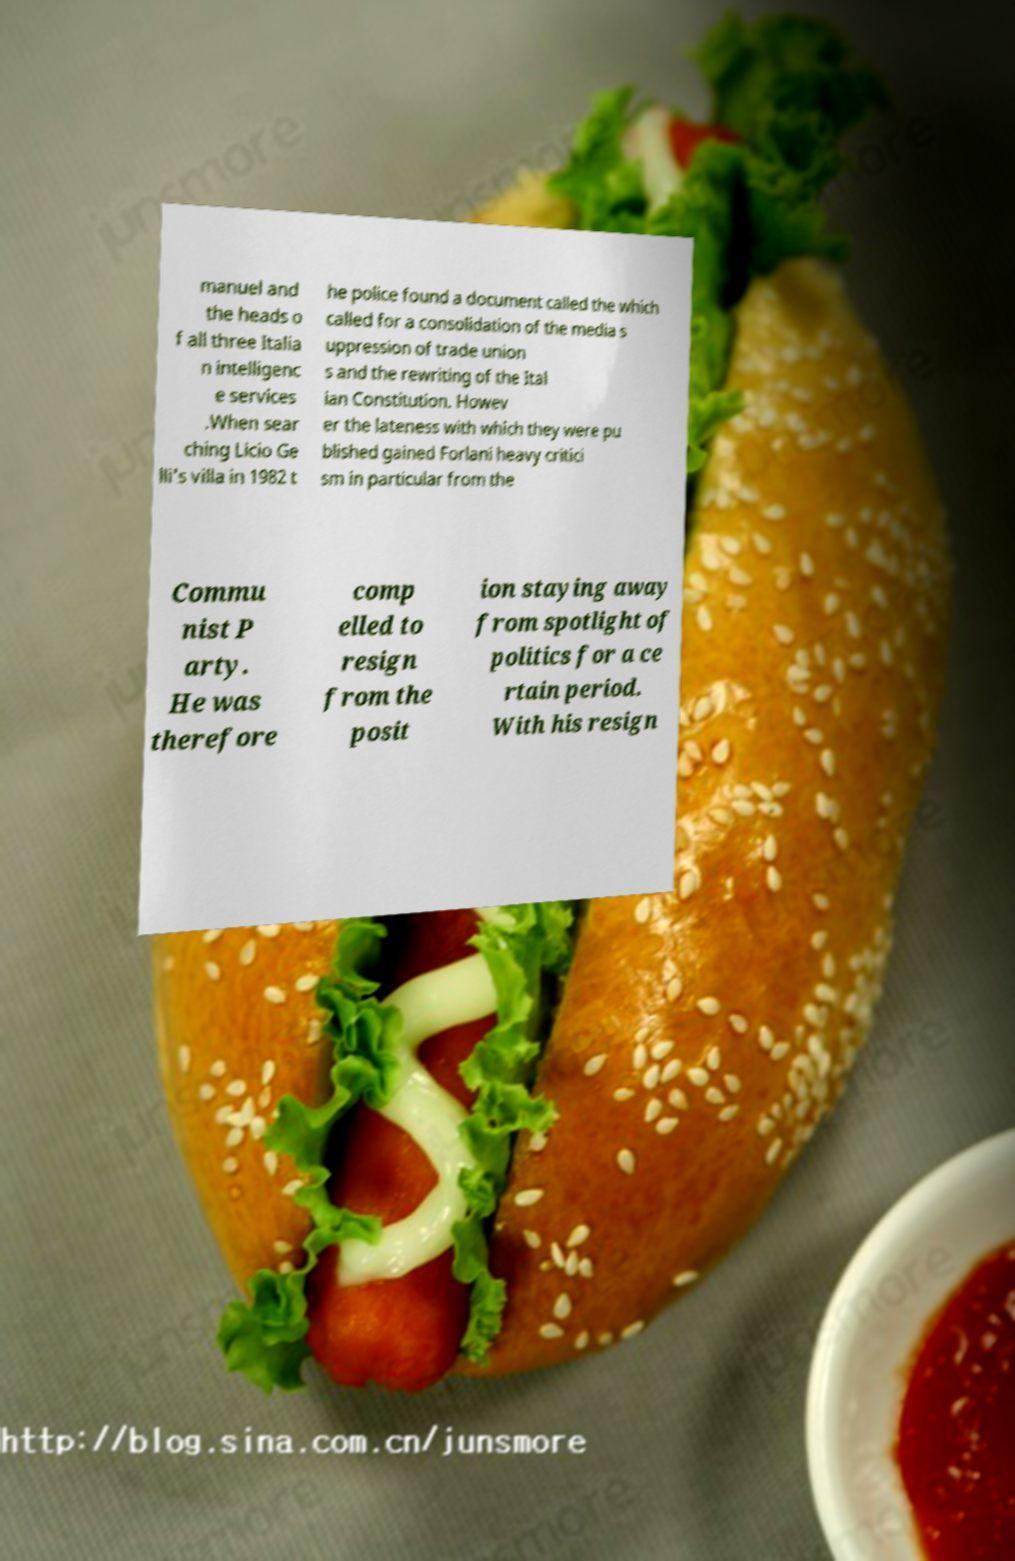Please identify and transcribe the text found in this image. manuel and the heads o f all three Italia n intelligenc e services .When sear ching Licio Ge lli's villa in 1982 t he police found a document called the which called for a consolidation of the media s uppression of trade union s and the rewriting of the Ital ian Constitution. Howev er the lateness with which they were pu blished gained Forlani heavy critici sm in particular from the Commu nist P arty. He was therefore comp elled to resign from the posit ion staying away from spotlight of politics for a ce rtain period. With his resign 